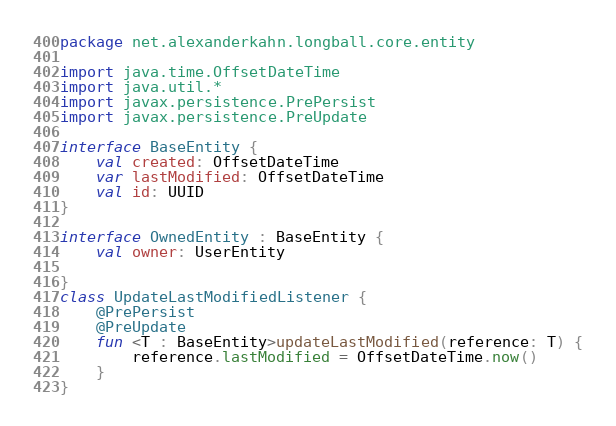<code> <loc_0><loc_0><loc_500><loc_500><_Kotlin_>package net.alexanderkahn.longball.core.entity

import java.time.OffsetDateTime
import java.util.*
import javax.persistence.PrePersist
import javax.persistence.PreUpdate

interface BaseEntity {
    val created: OffsetDateTime
    var lastModified: OffsetDateTime
    val id: UUID
}

interface OwnedEntity : BaseEntity {
    val owner: UserEntity

}
class UpdateLastModifiedListener {
    @PrePersist
    @PreUpdate
    fun <T : BaseEntity>updateLastModified(reference: T) {
        reference.lastModified = OffsetDateTime.now()
    }
}</code> 